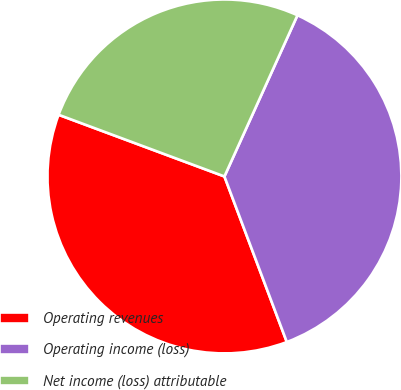Convert chart to OTSL. <chart><loc_0><loc_0><loc_500><loc_500><pie_chart><fcel>Operating revenues<fcel>Operating income (loss)<fcel>Net income (loss) attributable<nl><fcel>36.4%<fcel>37.49%<fcel>26.1%<nl></chart> 